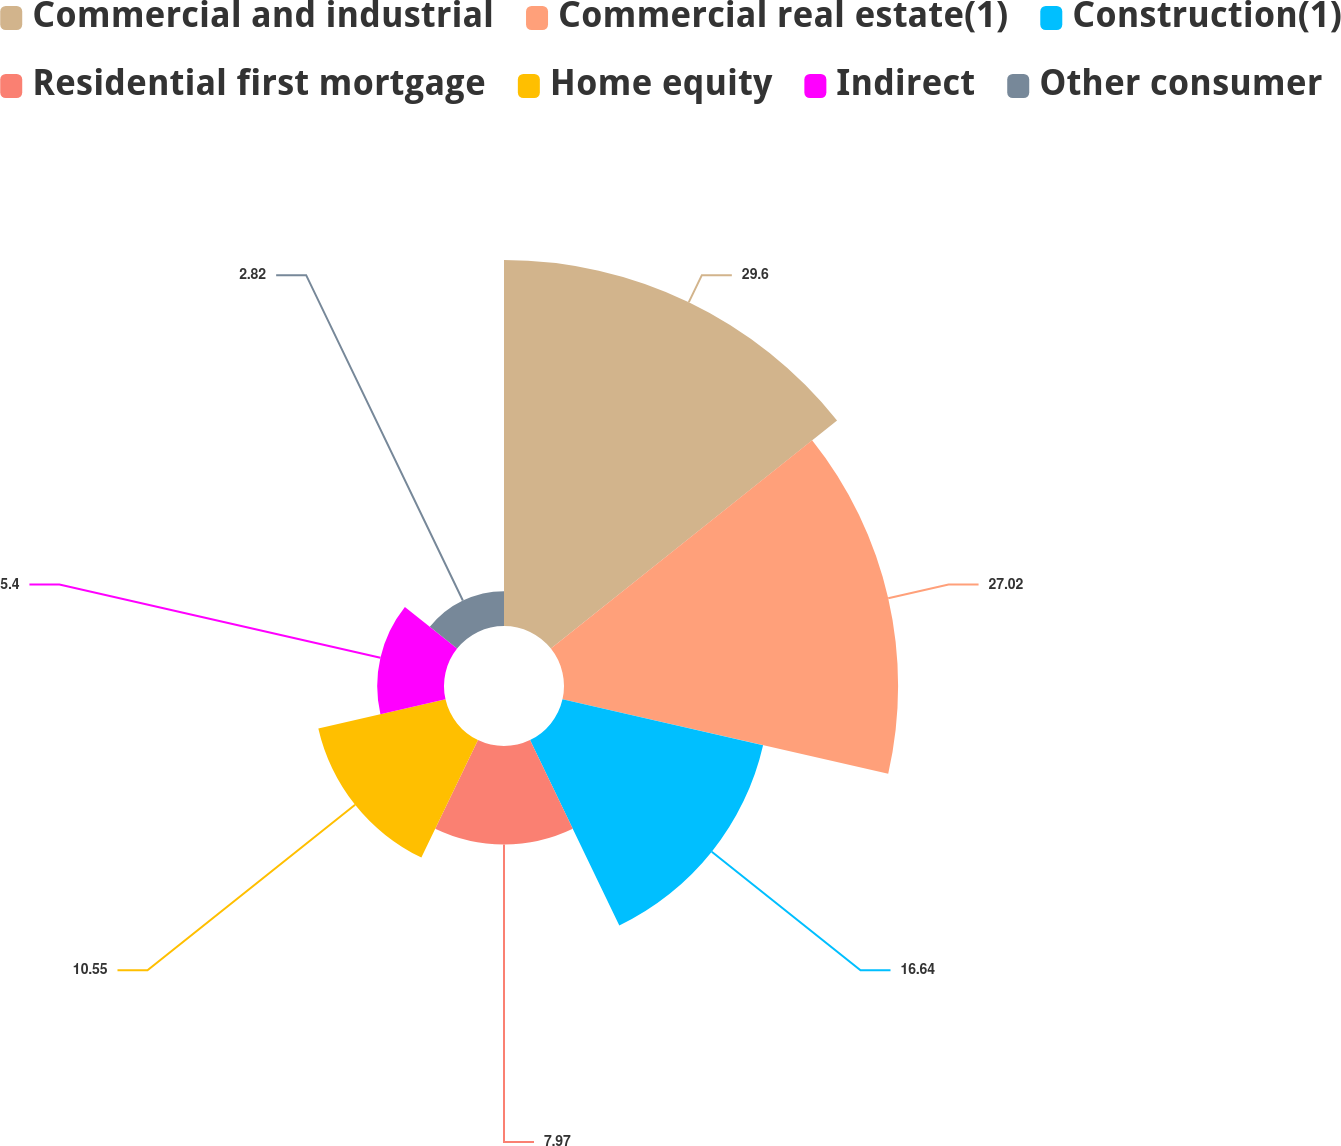Convert chart. <chart><loc_0><loc_0><loc_500><loc_500><pie_chart><fcel>Commercial and industrial<fcel>Commercial real estate(1)<fcel>Construction(1)<fcel>Residential first mortgage<fcel>Home equity<fcel>Indirect<fcel>Other consumer<nl><fcel>29.6%<fcel>27.02%<fcel>16.64%<fcel>7.97%<fcel>10.55%<fcel>5.4%<fcel>2.82%<nl></chart> 